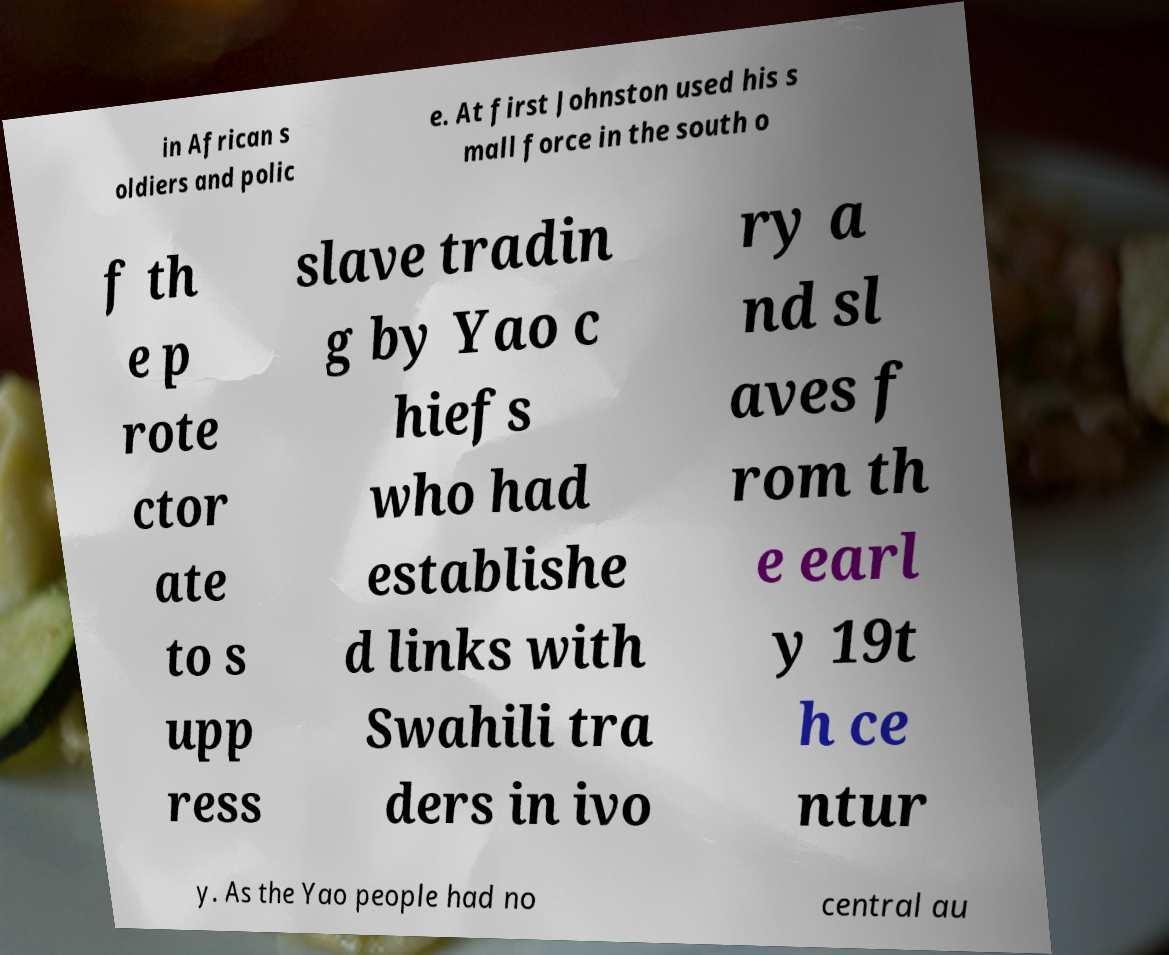For documentation purposes, I need the text within this image transcribed. Could you provide that? in African s oldiers and polic e. At first Johnston used his s mall force in the south o f th e p rote ctor ate to s upp ress slave tradin g by Yao c hiefs who had establishe d links with Swahili tra ders in ivo ry a nd sl aves f rom th e earl y 19t h ce ntur y. As the Yao people had no central au 